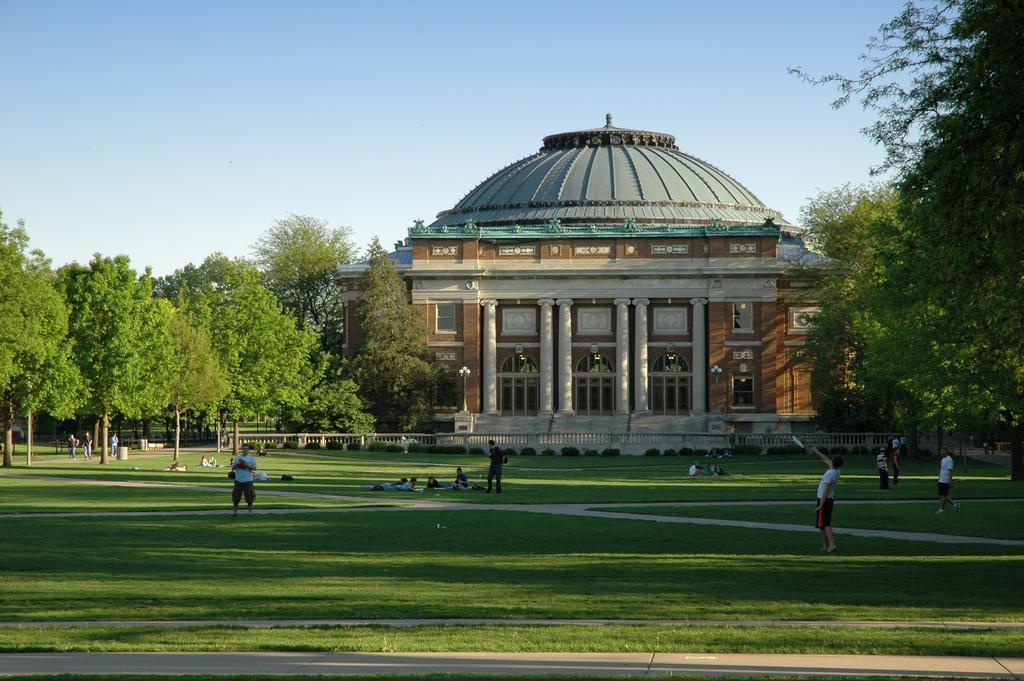Please provide a concise description of this image. This image is clicked in a lawn. There are a few people playing and a few lying on the ground. Behind them there is a building. In front of the building there is a railing. On the either sides of the building there are trees. At the top there is the sky. At the bottom there is grass on the ground. 